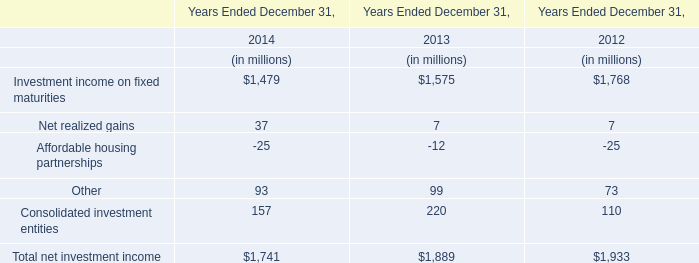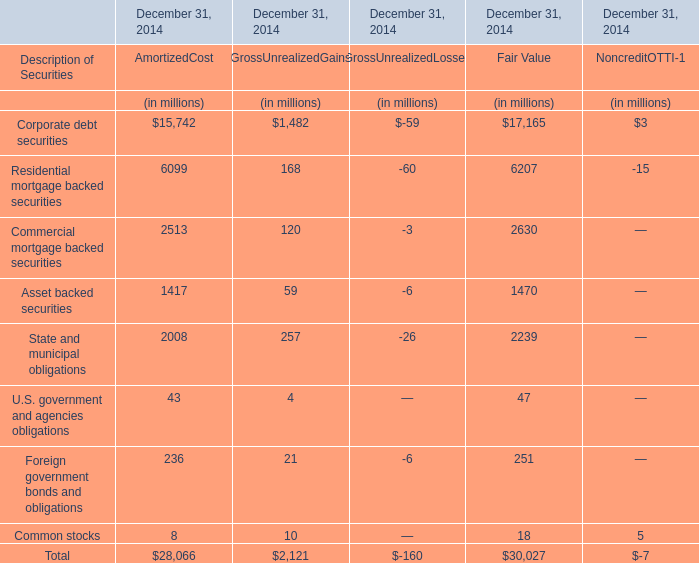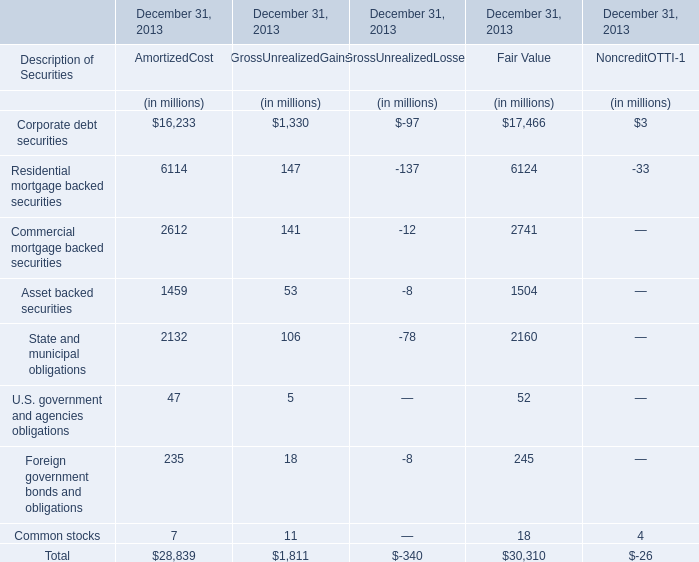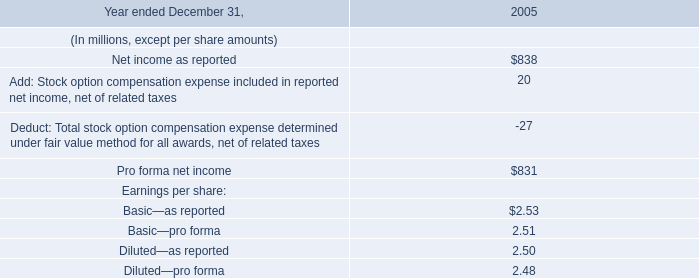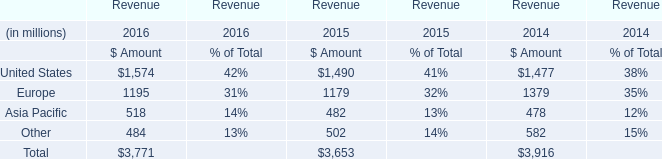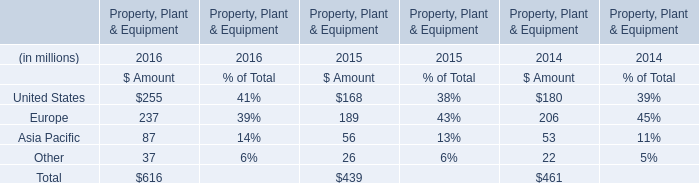What's the difference of Net realized gains between 2014 and 2013? (in millions) 
Computations: (37 - 7)
Answer: 30.0. 